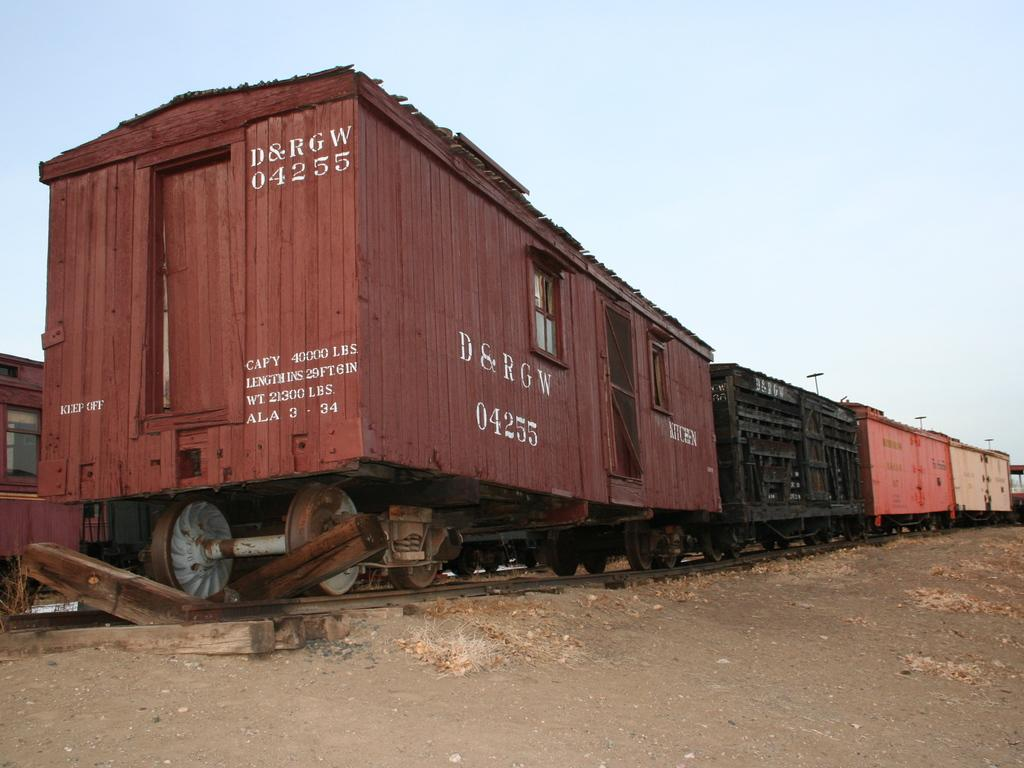Provide a one-sentence caption for the provided image. The back of a railroad car has the ID D&RGW 04255. 